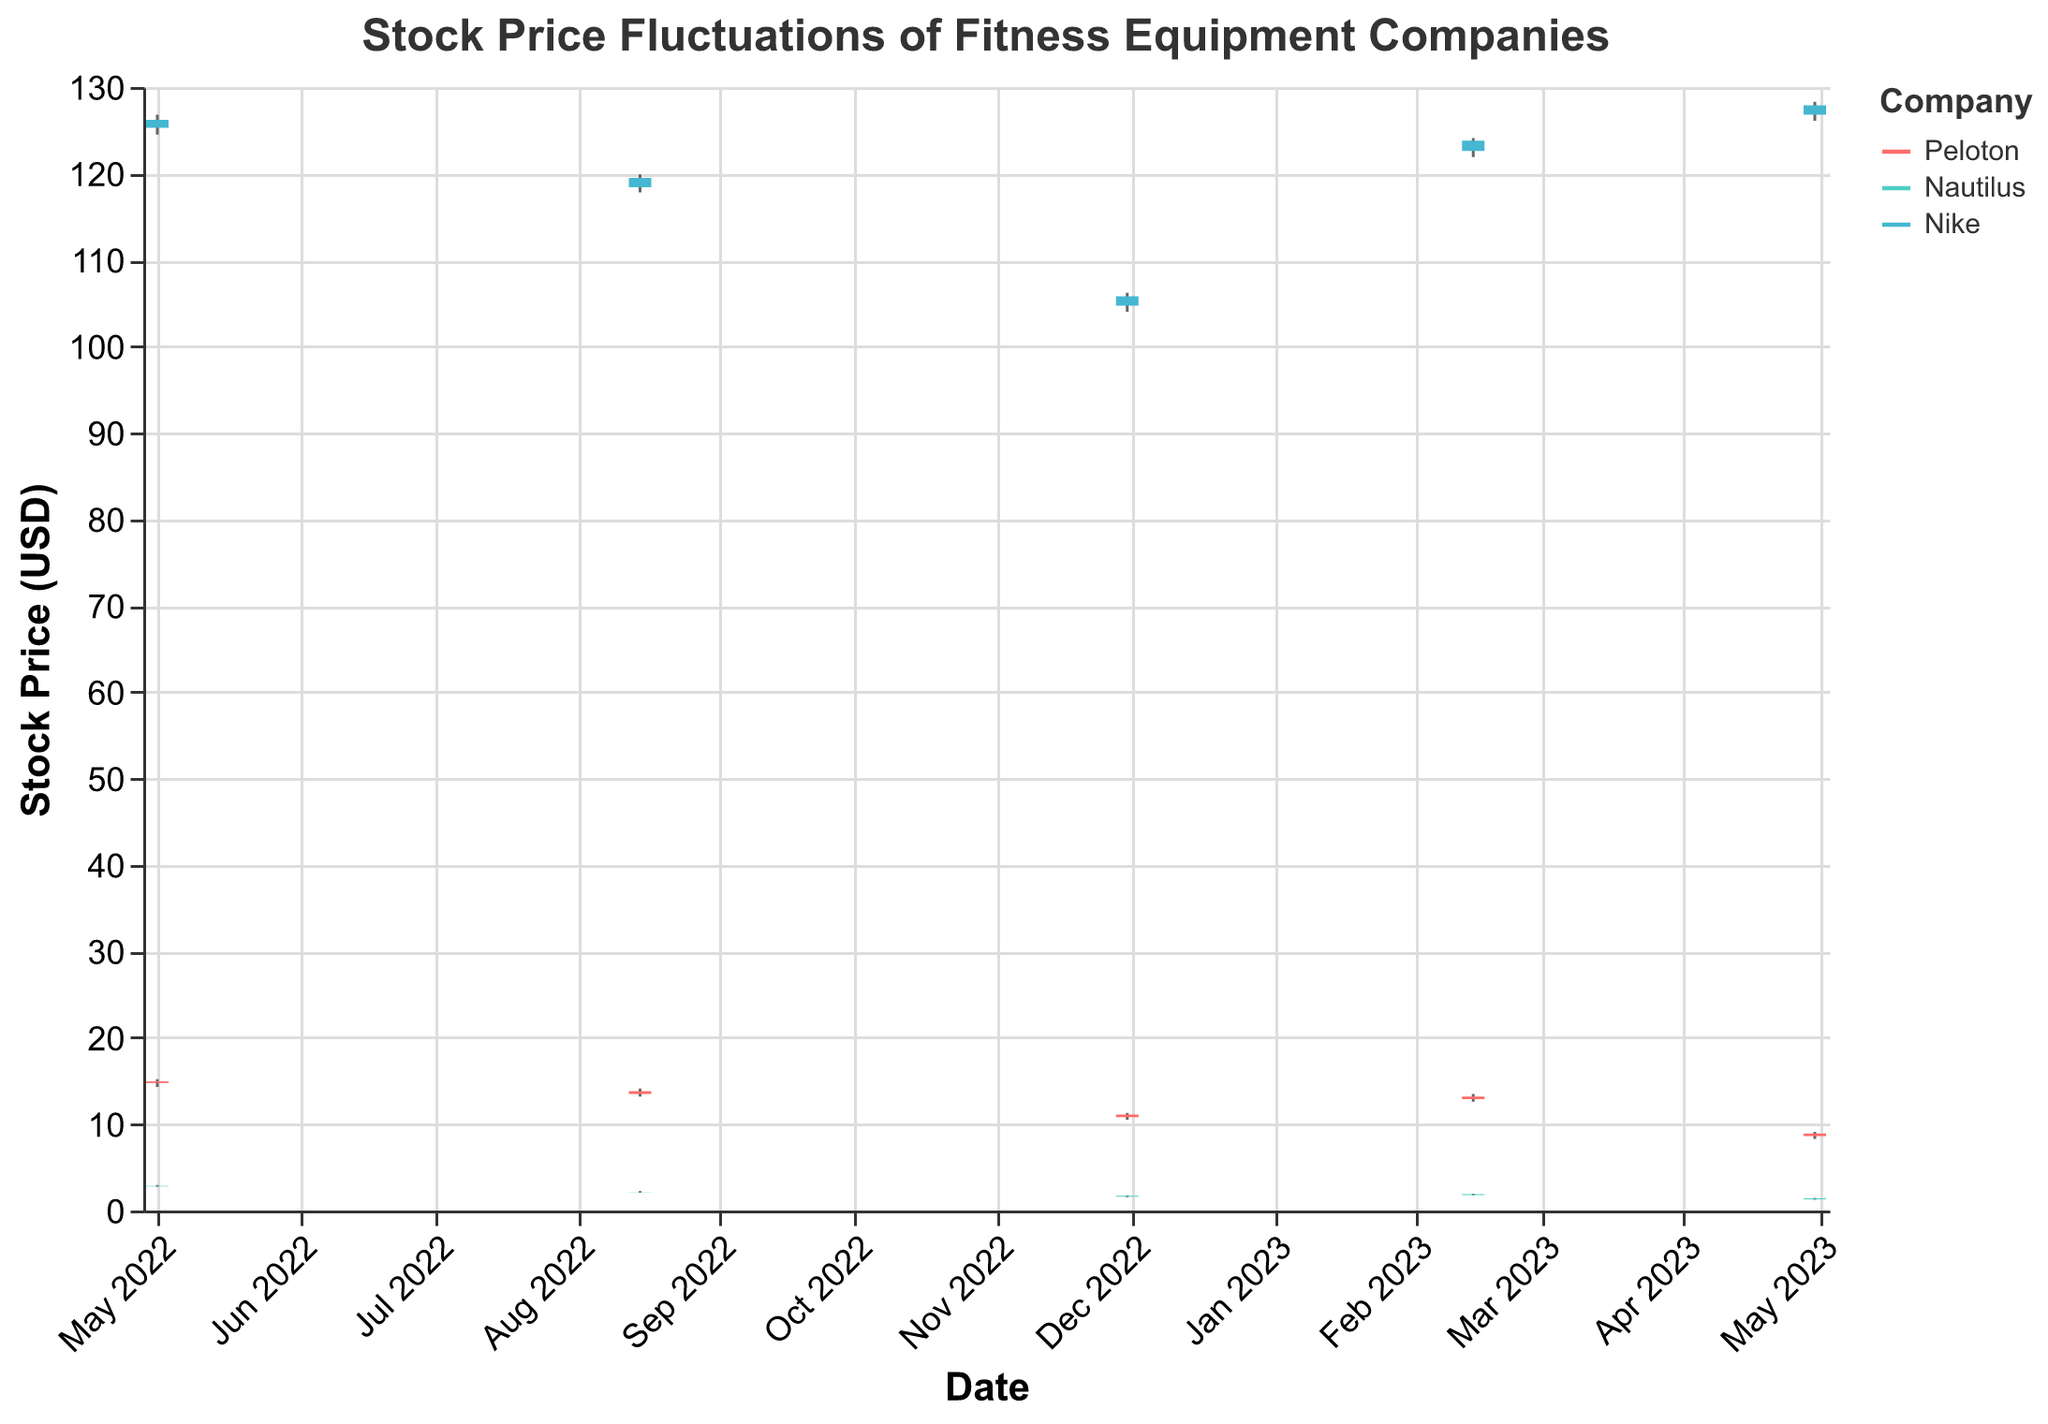What is the highest stock price recorded for Nike? To find the highest stock price for Nike, look for the maximum value in the 'High' field for Nike across all dates. The highest recorded value is 128.30 on April 30, 2023.
Answer: 128.30 Which company had the lowest closing price on November 30, 2022? For November 30, 2022, check the 'Close' field values for Peloton, Nautilus, and Nike. Nautilus has the lowest closing price of 1.70.
Answer: Nautilus How much did Peloton's closing price change between February 14, 2023, and April 30, 2023? Subtract Peloton's closing price on April 30, 2023 (8.90) from its closing price on February 14, 2023 (13.20): 13.20 - 8.90 = 4.30.
Answer: 4.30 Among the three companies on August 15, 2022, which had the smallest difference between the high and low prices? Calculate the difference between the 'High' and 'Low' prices for each company on August 15, 2022. Peloton: 14.10-13.20 = 0.90, Nautilus: 2.25-2.05 = 0.20, and Nike: 119.90-117.80 = 2.10. Nautilus has the smallest difference.
Answer: Nautilus What was the closing price of Nautilus on May 1, 2022, and how does it compare to its closing price on August 15, 2022? Check the 'Close' values for Nautilus on May 1, 2022 (2.85) and August 15, 2022 (2.15). Subtract to find the difference: 2.85 - 2.15 = 0.70. The closing price on May 1, 2022, was 0.70 higher than on August 15, 2022.
Answer: 2.85; 0.70 higher Which company's stock had the most significant drop in closing price between May 1, 2022, and the next data point (August 15, 2022)? Calculate the difference between the 'Close' values for each company between May 1, 2022, and August 15, 2022. Peloton: 14.95-13.80 = 1.15, Nautilus: 2.85-2.15 = 0.70, and Nike: 126.20-119.50 = 6.70. Nike had the most significant drop of 6.70.
Answer: Nike Which date had the highest average closing prices across all companies? Compute the average closing price for all companies on each date and compare. May 1, 2022: (14.95 + 2.85 + 126.20)/3 = 48.67, August 15, 2022: (13.80 + 2.15 + 119.50)/3 = 45.15, November 30, 2022: (11.10 + 1.70 + 105.80)/3 = 39.53, February 14, 2023: (13.20 + 1.90 + 123.80)/3 = 46.30, April 30, 2023: (8.90 + 1.40 + 127.90)/3 = 46.73. May 1, 2022 had the highest average closing prices of 48.67.
Answer: May 1, 2022 